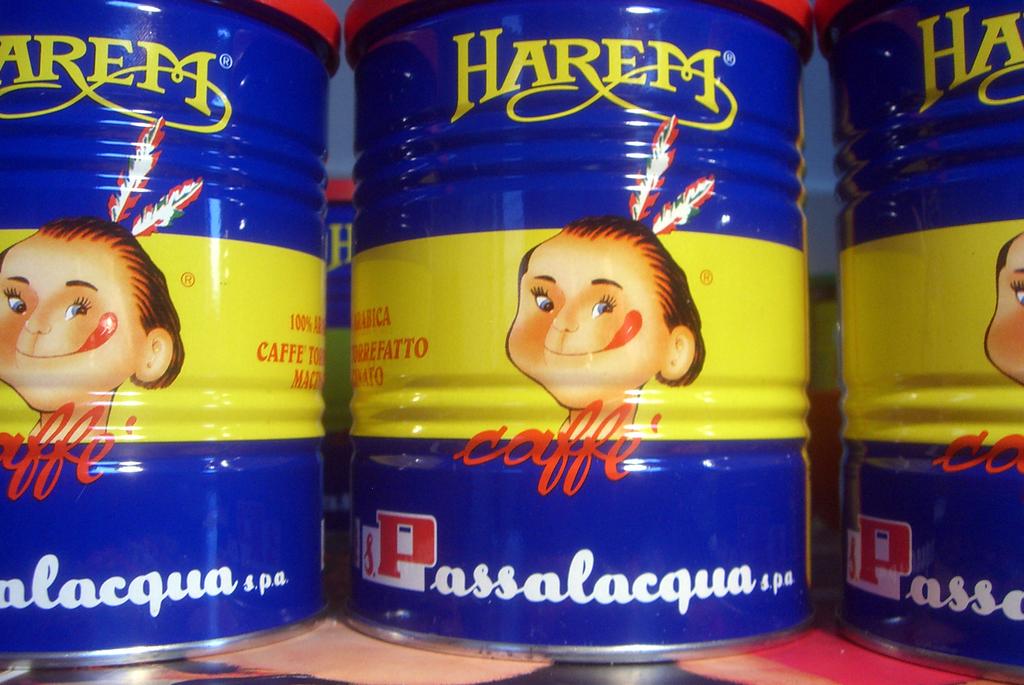What brand of coffee is this?
Your response must be concise. Harem. What word is under the face?
Your answer should be very brief. Caffe. 